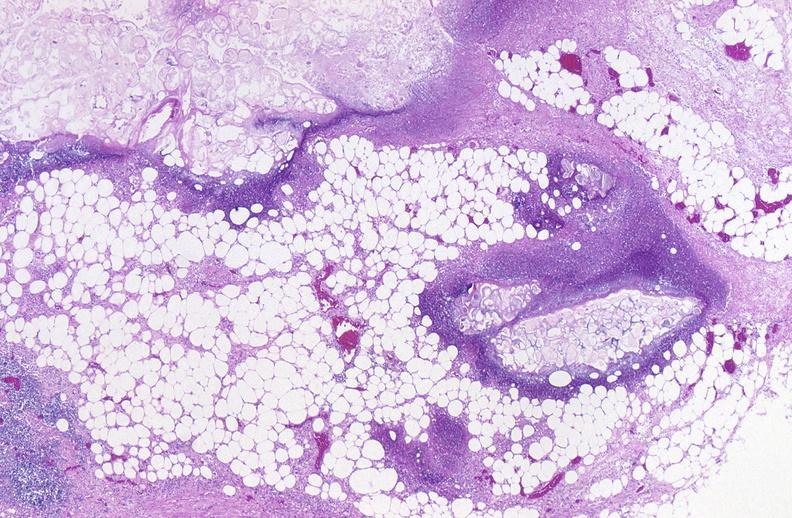does amebiasis show pancreatic fat necrosis?
Answer the question using a single word or phrase. No 